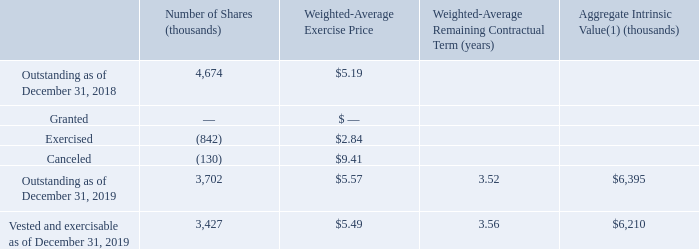Stock options
The following tables summarize our stock option activities and related information:
(1) The aggregate intrinsic value represents the excess of the closing price of our common stock of $6.87 as of December 31, 2019 over theexercise price of the outstanding in-the-money options.
What is the number of outstanding shares granted as of December 31, 2018? 
Answer scale should be: thousand. 4,674. What is the number of shares exercised as of December 31, 2018? 
Answer scale should be: thousand. (842). What is the number of shares canceled as of December 31, 2018? 
Answer scale should be: thousand. (130). What is the total amount spent on the canceled shares?
Answer scale should be: thousand. (130)* $9.41 
Answer: -1223.3. What is difference on the aggregate intrinsic value between Outstanding and Vested and exercisable as of December 31, 2019?
Answer scale should be: thousand. $6,395-$6,210
Answer: 185. What is the difference in outstanding shares as of December 31, 2018 and 2019?
Answer scale should be: thousand. 4,674 - 3,702 
Answer: 972. 